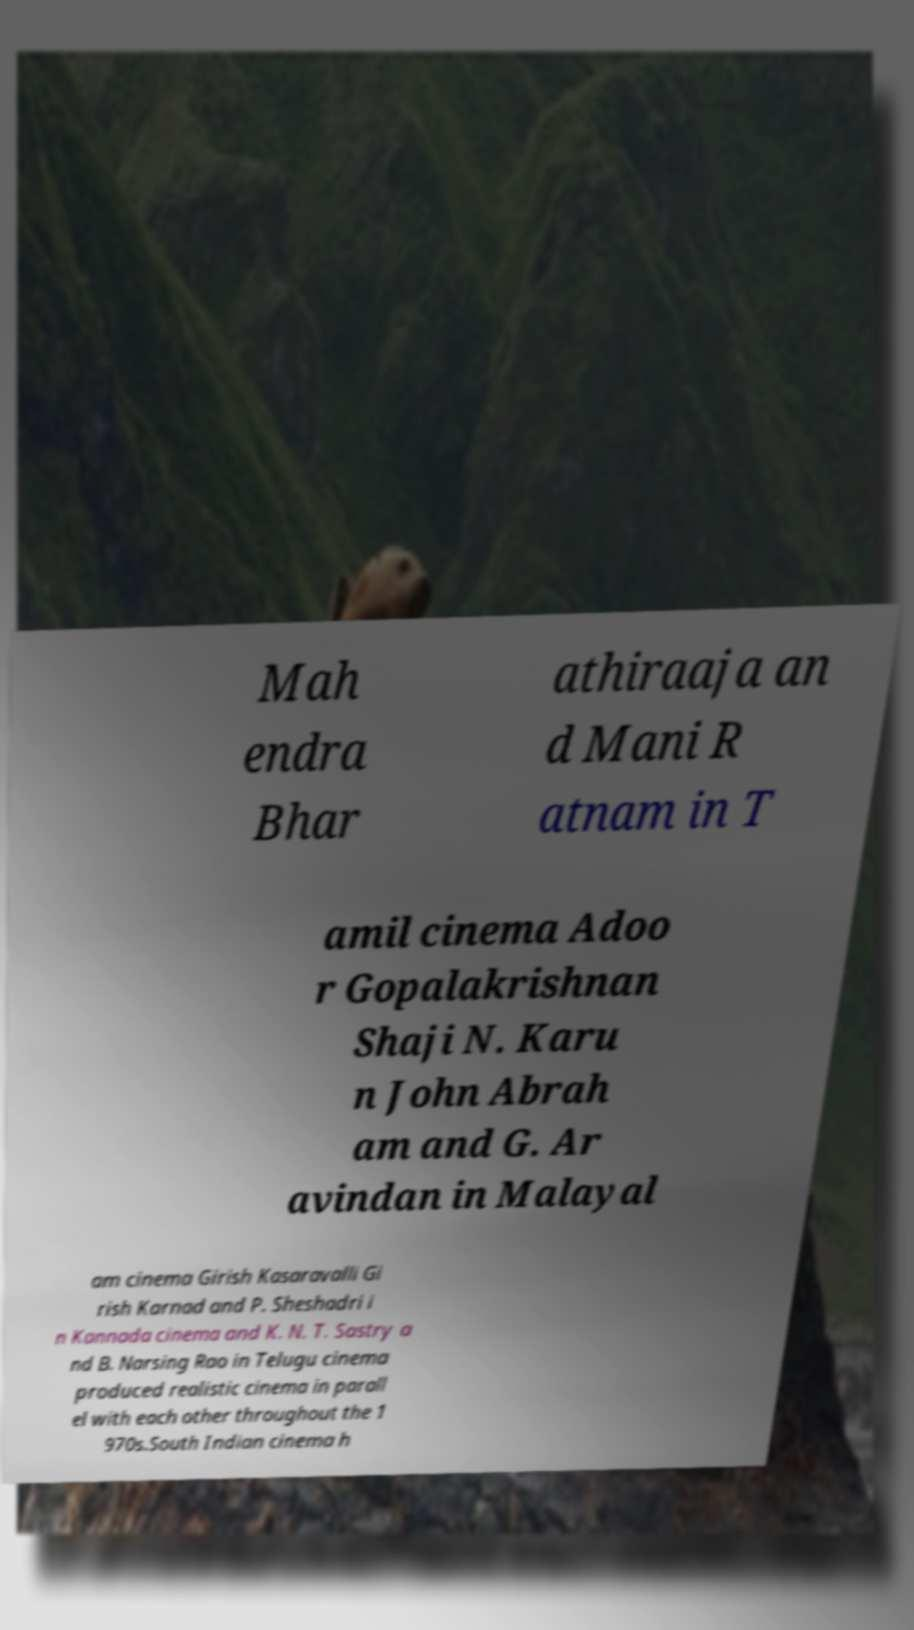For documentation purposes, I need the text within this image transcribed. Could you provide that? Mah endra Bhar athiraaja an d Mani R atnam in T amil cinema Adoo r Gopalakrishnan Shaji N. Karu n John Abrah am and G. Ar avindan in Malayal am cinema Girish Kasaravalli Gi rish Karnad and P. Sheshadri i n Kannada cinema and K. N. T. Sastry a nd B. Narsing Rao in Telugu cinema produced realistic cinema in parall el with each other throughout the 1 970s.South Indian cinema h 